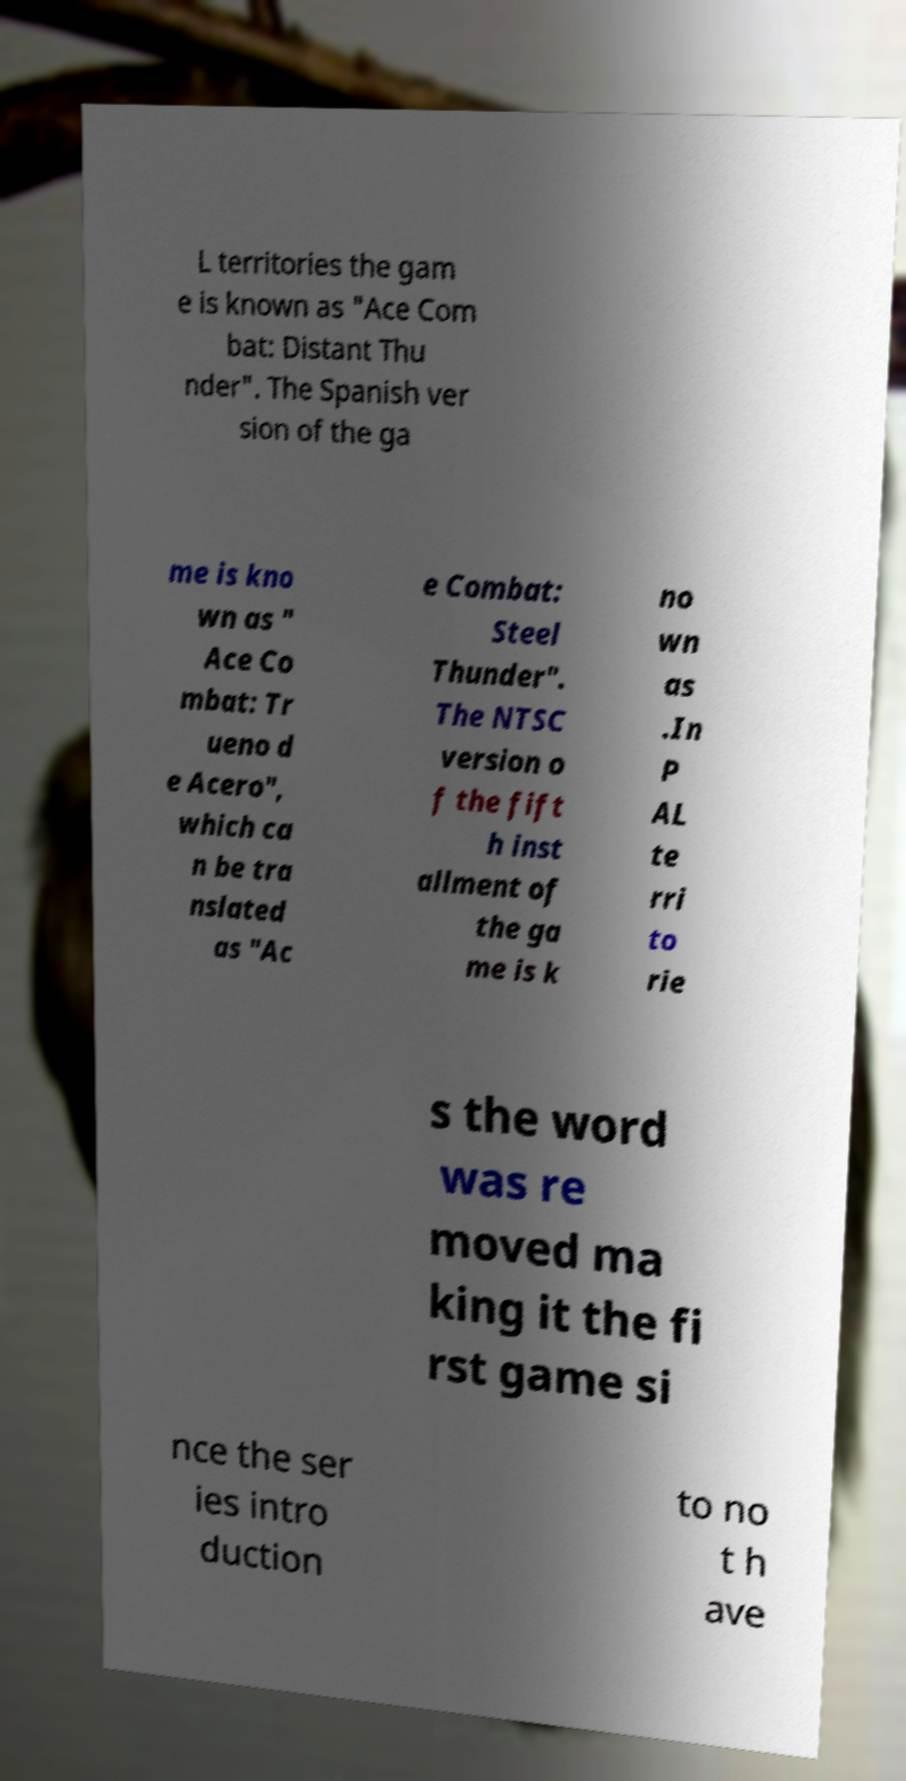Can you accurately transcribe the text from the provided image for me? L territories the gam e is known as "Ace Com bat: Distant Thu nder". The Spanish ver sion of the ga me is kno wn as " Ace Co mbat: Tr ueno d e Acero", which ca n be tra nslated as "Ac e Combat: Steel Thunder". The NTSC version o f the fift h inst allment of the ga me is k no wn as .In P AL te rri to rie s the word was re moved ma king it the fi rst game si nce the ser ies intro duction to no t h ave 